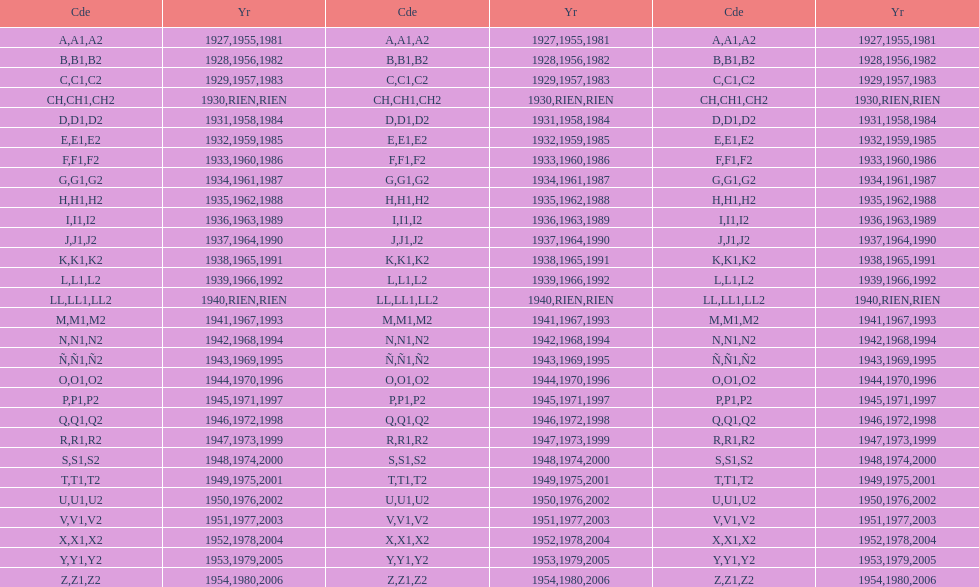List each code not associated to a year. CH1, CH2, LL1, LL2. Write the full table. {'header': ['Cde', 'Yr', 'Cde', 'Yr', 'Cde', 'Yr'], 'rows': [['A', '1927', 'A1', '1955', 'A2', '1981'], ['B', '1928', 'B1', '1956', 'B2', '1982'], ['C', '1929', 'C1', '1957', 'C2', '1983'], ['CH', '1930', 'CH1', 'RIEN', 'CH2', 'RIEN'], ['D', '1931', 'D1', '1958', 'D2', '1984'], ['E', '1932', 'E1', '1959', 'E2', '1985'], ['F', '1933', 'F1', '1960', 'F2', '1986'], ['G', '1934', 'G1', '1961', 'G2', '1987'], ['H', '1935', 'H1', '1962', 'H2', '1988'], ['I', '1936', 'I1', '1963', 'I2', '1989'], ['J', '1937', 'J1', '1964', 'J2', '1990'], ['K', '1938', 'K1', '1965', 'K2', '1991'], ['L', '1939', 'L1', '1966', 'L2', '1992'], ['LL', '1940', 'LL1', 'RIEN', 'LL2', 'RIEN'], ['M', '1941', 'M1', '1967', 'M2', '1993'], ['N', '1942', 'N1', '1968', 'N2', '1994'], ['Ñ', '1943', 'Ñ1', '1969', 'Ñ2', '1995'], ['O', '1944', 'O1', '1970', 'O2', '1996'], ['P', '1945', 'P1', '1971', 'P2', '1997'], ['Q', '1946', 'Q1', '1972', 'Q2', '1998'], ['R', '1947', 'R1', '1973', 'R2', '1999'], ['S', '1948', 'S1', '1974', 'S2', '2000'], ['T', '1949', 'T1', '1975', 'T2', '2001'], ['U', '1950', 'U1', '1976', 'U2', '2002'], ['V', '1951', 'V1', '1977', 'V2', '2003'], ['X', '1952', 'X1', '1978', 'X2', '2004'], ['Y', '1953', 'Y1', '1979', 'Y2', '2005'], ['Z', '1954', 'Z1', '1980', 'Z2', '2006']]} 